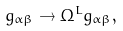Convert formula to latex. <formula><loc_0><loc_0><loc_500><loc_500>g _ { \alpha \beta } \rightarrow \Omega ^ { L } g _ { \alpha \beta } ,</formula> 